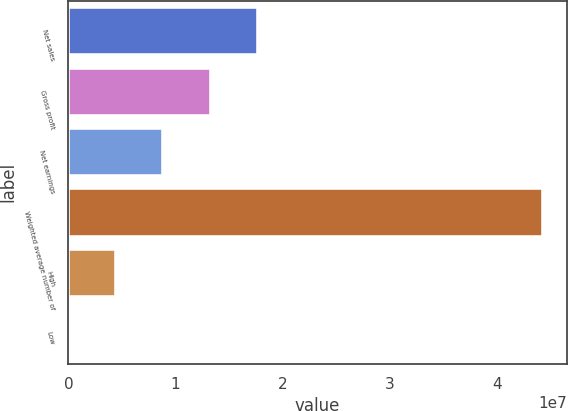Convert chart to OTSL. <chart><loc_0><loc_0><loc_500><loc_500><bar_chart><fcel>Net sales<fcel>Gross profit<fcel>Net earnings<fcel>Weighted average number of<fcel>High<fcel>Low<nl><fcel>1.77282e+07<fcel>1.32962e+07<fcel>8.86413e+06<fcel>4.43205e+07<fcel>4.43208e+06<fcel>40.5<nl></chart> 